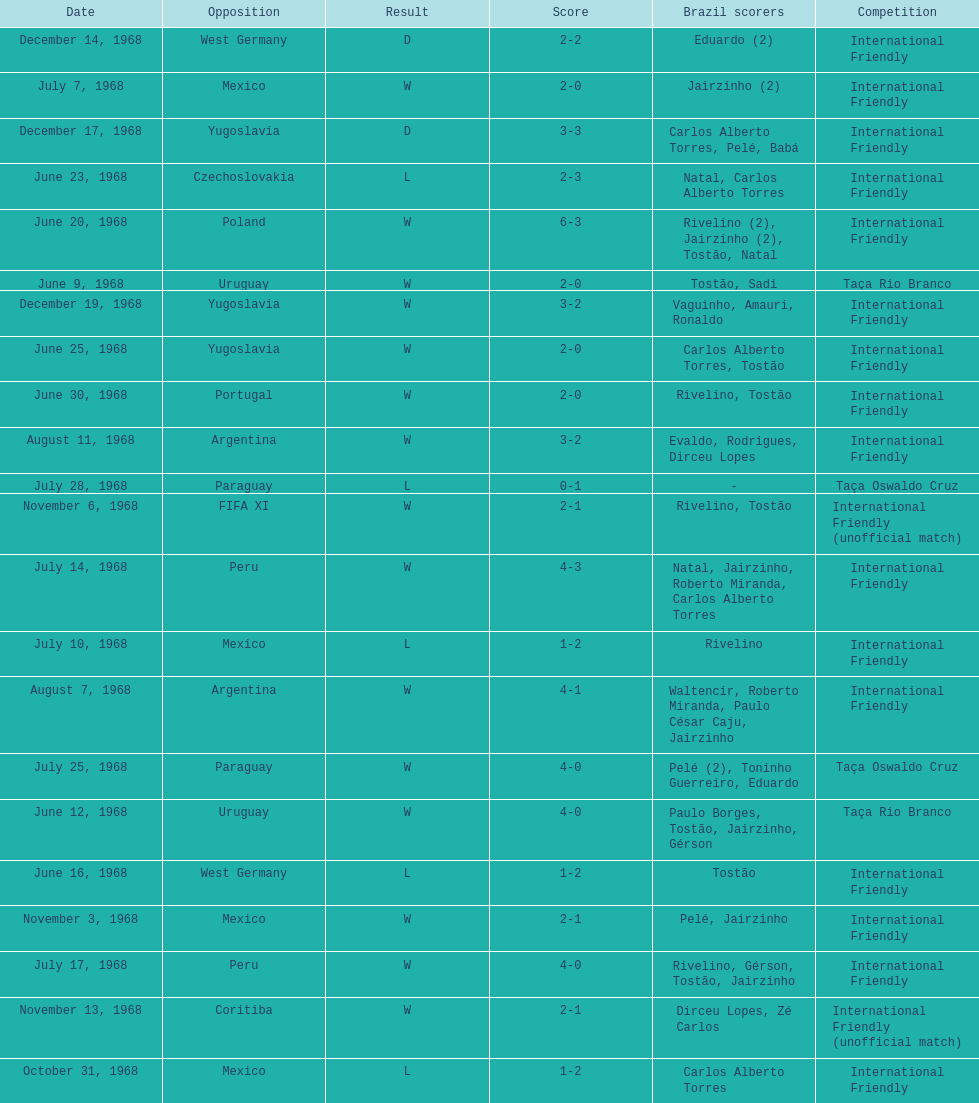Who played brazil previous to the game on june 30th? Yugoslavia. 